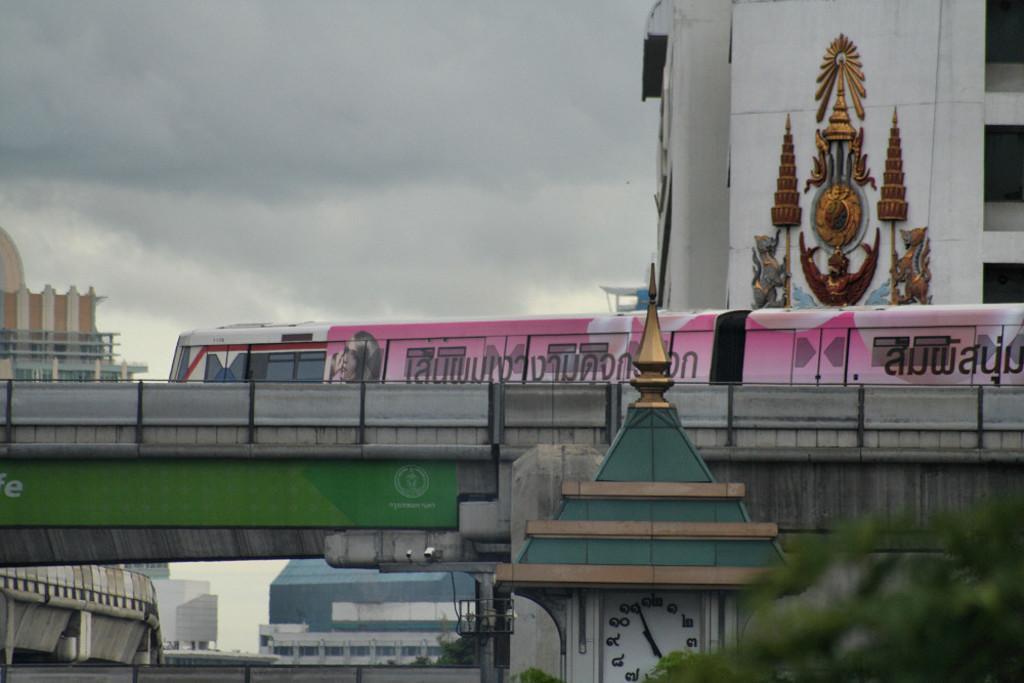How would you summarize this image in a sentence or two? In the bottom right there is a tree and a clock tower, in the background there is a bridge on that bridge there is a train and there are buildings and the sky. 